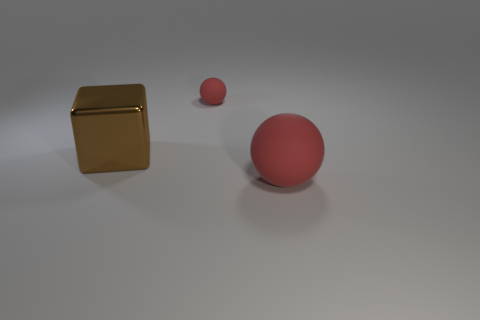Add 2 small metal cylinders. How many objects exist? 5 Subtract all spheres. How many objects are left? 1 Add 2 rubber spheres. How many rubber spheres exist? 4 Subtract 0 yellow balls. How many objects are left? 3 Subtract 1 cubes. How many cubes are left? 0 Subtract all green blocks. Subtract all purple balls. How many blocks are left? 1 Subtract all big brown cubes. Subtract all red balls. How many objects are left? 0 Add 2 big cubes. How many big cubes are left? 3 